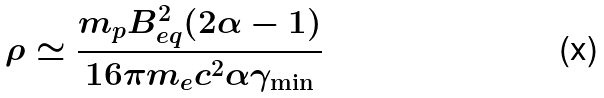<formula> <loc_0><loc_0><loc_500><loc_500>\rho \simeq \frac { m _ { p } B _ { e q } ^ { 2 } ( 2 \alpha - 1 ) } { 1 6 \pi m _ { e } c ^ { 2 } \alpha \gamma _ { \min } }</formula> 